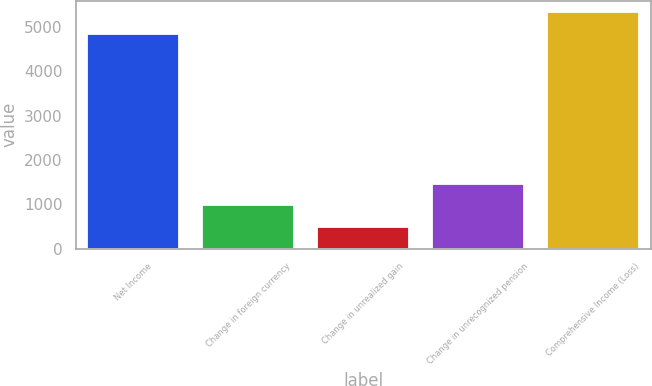Convert chart to OTSL. <chart><loc_0><loc_0><loc_500><loc_500><bar_chart><fcel>Net Income<fcel>Change in foreign currency<fcel>Change in unrealized gain<fcel>Change in unrecognized pension<fcel>Comprehensive Income (Loss)<nl><fcel>4844<fcel>980.4<fcel>490.7<fcel>1470.1<fcel>5333.7<nl></chart> 